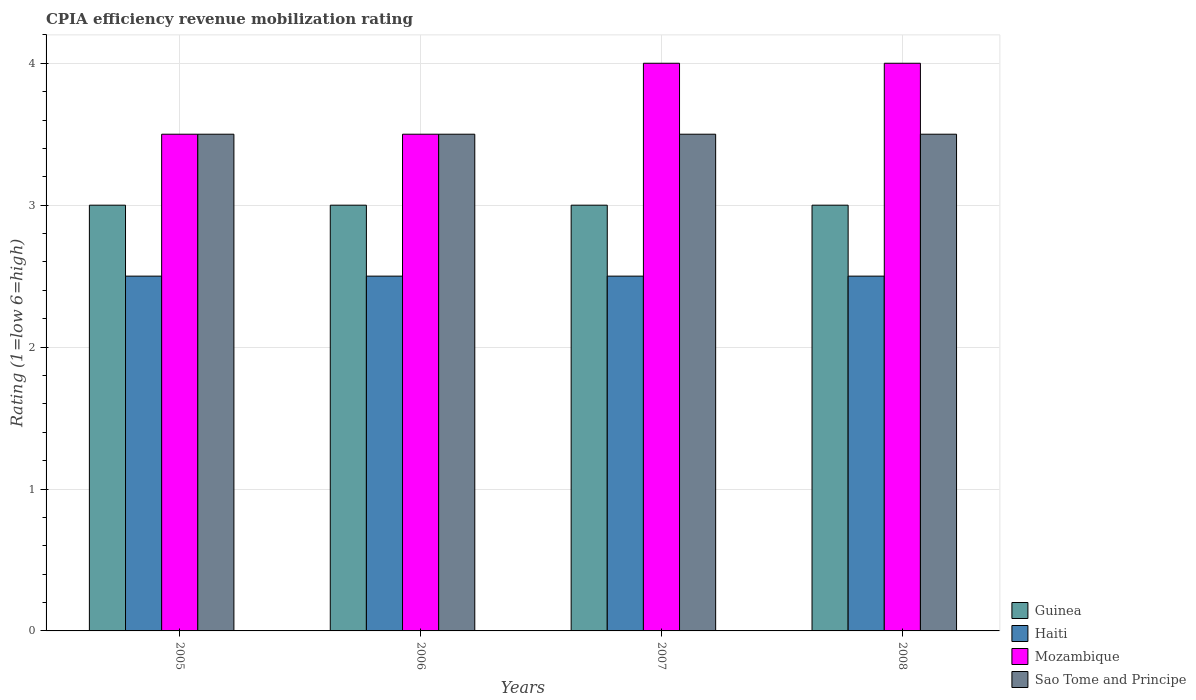How many different coloured bars are there?
Make the answer very short. 4. Are the number of bars on each tick of the X-axis equal?
Offer a terse response. Yes. How many bars are there on the 3rd tick from the left?
Provide a short and direct response. 4. What is the label of the 3rd group of bars from the left?
Give a very brief answer. 2007. In how many cases, is the number of bars for a given year not equal to the number of legend labels?
Give a very brief answer. 0. What is the CPIA rating in Guinea in 2007?
Your answer should be very brief. 3. Across all years, what is the maximum CPIA rating in Mozambique?
Your answer should be very brief. 4. In which year was the CPIA rating in Mozambique minimum?
Make the answer very short. 2005. What is the difference between the CPIA rating in Sao Tome and Principe in 2007 and the CPIA rating in Haiti in 2005?
Give a very brief answer. 1. Is the CPIA rating in Haiti in 2005 less than that in 2007?
Give a very brief answer. No. What is the difference between the highest and the second highest CPIA rating in Sao Tome and Principe?
Ensure brevity in your answer.  0. In how many years, is the CPIA rating in Guinea greater than the average CPIA rating in Guinea taken over all years?
Offer a very short reply. 0. Is the sum of the CPIA rating in Sao Tome and Principe in 2006 and 2007 greater than the maximum CPIA rating in Haiti across all years?
Your answer should be compact. Yes. What does the 2nd bar from the left in 2008 represents?
Your answer should be compact. Haiti. What does the 2nd bar from the right in 2005 represents?
Offer a terse response. Mozambique. How many bars are there?
Your answer should be very brief. 16. Are the values on the major ticks of Y-axis written in scientific E-notation?
Provide a succinct answer. No. Does the graph contain any zero values?
Keep it short and to the point. No. Where does the legend appear in the graph?
Make the answer very short. Bottom right. How many legend labels are there?
Offer a very short reply. 4. What is the title of the graph?
Your response must be concise. CPIA efficiency revenue mobilization rating. What is the label or title of the Y-axis?
Offer a very short reply. Rating (1=low 6=high). What is the Rating (1=low 6=high) in Guinea in 2005?
Keep it short and to the point. 3. What is the Rating (1=low 6=high) of Mozambique in 2005?
Offer a very short reply. 3.5. What is the Rating (1=low 6=high) in Sao Tome and Principe in 2005?
Provide a short and direct response. 3.5. What is the Rating (1=low 6=high) in Haiti in 2006?
Your answer should be compact. 2.5. What is the Rating (1=low 6=high) in Sao Tome and Principe in 2006?
Offer a terse response. 3.5. What is the Rating (1=low 6=high) in Guinea in 2007?
Your response must be concise. 3. What is the Rating (1=low 6=high) in Mozambique in 2007?
Your response must be concise. 4. What is the Rating (1=low 6=high) in Sao Tome and Principe in 2007?
Ensure brevity in your answer.  3.5. What is the Rating (1=low 6=high) of Guinea in 2008?
Ensure brevity in your answer.  3. What is the Rating (1=low 6=high) of Haiti in 2008?
Ensure brevity in your answer.  2.5. What is the Rating (1=low 6=high) in Mozambique in 2008?
Make the answer very short. 4. Across all years, what is the maximum Rating (1=low 6=high) in Guinea?
Provide a short and direct response. 3. Across all years, what is the maximum Rating (1=low 6=high) of Mozambique?
Offer a very short reply. 4. Across all years, what is the minimum Rating (1=low 6=high) of Guinea?
Your response must be concise. 3. Across all years, what is the minimum Rating (1=low 6=high) in Sao Tome and Principe?
Your answer should be very brief. 3.5. What is the total Rating (1=low 6=high) of Guinea in the graph?
Provide a short and direct response. 12. What is the total Rating (1=low 6=high) in Mozambique in the graph?
Give a very brief answer. 15. What is the total Rating (1=low 6=high) of Sao Tome and Principe in the graph?
Provide a short and direct response. 14. What is the difference between the Rating (1=low 6=high) in Guinea in 2005 and that in 2006?
Make the answer very short. 0. What is the difference between the Rating (1=low 6=high) in Haiti in 2005 and that in 2006?
Offer a very short reply. 0. What is the difference between the Rating (1=low 6=high) of Sao Tome and Principe in 2005 and that in 2007?
Provide a short and direct response. 0. What is the difference between the Rating (1=low 6=high) of Guinea in 2005 and that in 2008?
Ensure brevity in your answer.  0. What is the difference between the Rating (1=low 6=high) in Mozambique in 2005 and that in 2008?
Provide a succinct answer. -0.5. What is the difference between the Rating (1=low 6=high) of Sao Tome and Principe in 2005 and that in 2008?
Provide a short and direct response. 0. What is the difference between the Rating (1=low 6=high) of Mozambique in 2006 and that in 2007?
Keep it short and to the point. -0.5. What is the difference between the Rating (1=low 6=high) in Guinea in 2006 and that in 2008?
Keep it short and to the point. 0. What is the difference between the Rating (1=low 6=high) in Guinea in 2007 and that in 2008?
Your answer should be compact. 0. What is the difference between the Rating (1=low 6=high) of Haiti in 2007 and that in 2008?
Provide a short and direct response. 0. What is the difference between the Rating (1=low 6=high) in Sao Tome and Principe in 2007 and that in 2008?
Your answer should be compact. 0. What is the difference between the Rating (1=low 6=high) in Guinea in 2005 and the Rating (1=low 6=high) in Haiti in 2006?
Your answer should be compact. 0.5. What is the difference between the Rating (1=low 6=high) of Guinea in 2005 and the Rating (1=low 6=high) of Sao Tome and Principe in 2006?
Your response must be concise. -0.5. What is the difference between the Rating (1=low 6=high) in Haiti in 2005 and the Rating (1=low 6=high) in Mozambique in 2006?
Your response must be concise. -1. What is the difference between the Rating (1=low 6=high) of Haiti in 2005 and the Rating (1=low 6=high) of Sao Tome and Principe in 2006?
Offer a very short reply. -1. What is the difference between the Rating (1=low 6=high) of Mozambique in 2005 and the Rating (1=low 6=high) of Sao Tome and Principe in 2006?
Your answer should be very brief. 0. What is the difference between the Rating (1=low 6=high) in Guinea in 2005 and the Rating (1=low 6=high) in Mozambique in 2007?
Provide a short and direct response. -1. What is the difference between the Rating (1=low 6=high) of Guinea in 2005 and the Rating (1=low 6=high) of Sao Tome and Principe in 2007?
Your answer should be compact. -0.5. What is the difference between the Rating (1=low 6=high) in Haiti in 2005 and the Rating (1=low 6=high) in Sao Tome and Principe in 2007?
Your answer should be compact. -1. What is the difference between the Rating (1=low 6=high) in Mozambique in 2005 and the Rating (1=low 6=high) in Sao Tome and Principe in 2007?
Give a very brief answer. 0. What is the difference between the Rating (1=low 6=high) in Guinea in 2005 and the Rating (1=low 6=high) in Haiti in 2008?
Ensure brevity in your answer.  0.5. What is the difference between the Rating (1=low 6=high) in Guinea in 2005 and the Rating (1=low 6=high) in Mozambique in 2008?
Offer a terse response. -1. What is the difference between the Rating (1=low 6=high) in Haiti in 2005 and the Rating (1=low 6=high) in Mozambique in 2008?
Keep it short and to the point. -1.5. What is the difference between the Rating (1=low 6=high) in Haiti in 2005 and the Rating (1=low 6=high) in Sao Tome and Principe in 2008?
Provide a succinct answer. -1. What is the difference between the Rating (1=low 6=high) in Mozambique in 2005 and the Rating (1=low 6=high) in Sao Tome and Principe in 2008?
Your answer should be very brief. 0. What is the difference between the Rating (1=low 6=high) in Guinea in 2006 and the Rating (1=low 6=high) in Haiti in 2007?
Give a very brief answer. 0.5. What is the difference between the Rating (1=low 6=high) in Guinea in 2006 and the Rating (1=low 6=high) in Mozambique in 2007?
Make the answer very short. -1. What is the difference between the Rating (1=low 6=high) of Guinea in 2006 and the Rating (1=low 6=high) of Haiti in 2008?
Keep it short and to the point. 0.5. What is the difference between the Rating (1=low 6=high) in Guinea in 2006 and the Rating (1=low 6=high) in Mozambique in 2008?
Keep it short and to the point. -1. What is the difference between the Rating (1=low 6=high) in Haiti in 2006 and the Rating (1=low 6=high) in Mozambique in 2008?
Keep it short and to the point. -1.5. What is the difference between the Rating (1=low 6=high) of Guinea in 2007 and the Rating (1=low 6=high) of Mozambique in 2008?
Your answer should be compact. -1. What is the difference between the Rating (1=low 6=high) of Guinea in 2007 and the Rating (1=low 6=high) of Sao Tome and Principe in 2008?
Give a very brief answer. -0.5. What is the difference between the Rating (1=low 6=high) of Haiti in 2007 and the Rating (1=low 6=high) of Mozambique in 2008?
Provide a succinct answer. -1.5. What is the difference between the Rating (1=low 6=high) in Mozambique in 2007 and the Rating (1=low 6=high) in Sao Tome and Principe in 2008?
Ensure brevity in your answer.  0.5. What is the average Rating (1=low 6=high) in Guinea per year?
Ensure brevity in your answer.  3. What is the average Rating (1=low 6=high) in Mozambique per year?
Offer a terse response. 3.75. In the year 2005, what is the difference between the Rating (1=low 6=high) in Guinea and Rating (1=low 6=high) in Haiti?
Your answer should be compact. 0.5. In the year 2005, what is the difference between the Rating (1=low 6=high) in Haiti and Rating (1=low 6=high) in Sao Tome and Principe?
Your response must be concise. -1. In the year 2005, what is the difference between the Rating (1=low 6=high) of Mozambique and Rating (1=low 6=high) of Sao Tome and Principe?
Provide a succinct answer. 0. In the year 2006, what is the difference between the Rating (1=low 6=high) in Guinea and Rating (1=low 6=high) in Sao Tome and Principe?
Provide a succinct answer. -0.5. In the year 2006, what is the difference between the Rating (1=low 6=high) in Haiti and Rating (1=low 6=high) in Sao Tome and Principe?
Provide a succinct answer. -1. In the year 2007, what is the difference between the Rating (1=low 6=high) in Guinea and Rating (1=low 6=high) in Haiti?
Provide a short and direct response. 0.5. In the year 2007, what is the difference between the Rating (1=low 6=high) in Guinea and Rating (1=low 6=high) in Mozambique?
Keep it short and to the point. -1. In the year 2007, what is the difference between the Rating (1=low 6=high) in Guinea and Rating (1=low 6=high) in Sao Tome and Principe?
Offer a very short reply. -0.5. In the year 2007, what is the difference between the Rating (1=low 6=high) in Mozambique and Rating (1=low 6=high) in Sao Tome and Principe?
Provide a succinct answer. 0.5. In the year 2008, what is the difference between the Rating (1=low 6=high) in Guinea and Rating (1=low 6=high) in Haiti?
Your answer should be very brief. 0.5. In the year 2008, what is the difference between the Rating (1=low 6=high) in Guinea and Rating (1=low 6=high) in Sao Tome and Principe?
Make the answer very short. -0.5. In the year 2008, what is the difference between the Rating (1=low 6=high) of Haiti and Rating (1=low 6=high) of Mozambique?
Make the answer very short. -1.5. In the year 2008, what is the difference between the Rating (1=low 6=high) of Mozambique and Rating (1=low 6=high) of Sao Tome and Principe?
Give a very brief answer. 0.5. What is the ratio of the Rating (1=low 6=high) in Haiti in 2005 to that in 2006?
Your response must be concise. 1. What is the ratio of the Rating (1=low 6=high) in Sao Tome and Principe in 2005 to that in 2006?
Provide a short and direct response. 1. What is the ratio of the Rating (1=low 6=high) in Guinea in 2005 to that in 2007?
Offer a terse response. 1. What is the ratio of the Rating (1=low 6=high) of Mozambique in 2005 to that in 2007?
Your response must be concise. 0.88. What is the ratio of the Rating (1=low 6=high) in Mozambique in 2005 to that in 2008?
Keep it short and to the point. 0.88. What is the ratio of the Rating (1=low 6=high) in Sao Tome and Principe in 2005 to that in 2008?
Offer a very short reply. 1. What is the ratio of the Rating (1=low 6=high) in Haiti in 2006 to that in 2007?
Your answer should be very brief. 1. What is the ratio of the Rating (1=low 6=high) in Mozambique in 2006 to that in 2007?
Offer a very short reply. 0.88. What is the ratio of the Rating (1=low 6=high) in Sao Tome and Principe in 2006 to that in 2007?
Your answer should be very brief. 1. What is the ratio of the Rating (1=low 6=high) in Haiti in 2006 to that in 2008?
Your answer should be compact. 1. What is the ratio of the Rating (1=low 6=high) of Guinea in 2007 to that in 2008?
Provide a succinct answer. 1. What is the ratio of the Rating (1=low 6=high) in Haiti in 2007 to that in 2008?
Ensure brevity in your answer.  1. What is the ratio of the Rating (1=low 6=high) in Mozambique in 2007 to that in 2008?
Your response must be concise. 1. What is the ratio of the Rating (1=low 6=high) of Sao Tome and Principe in 2007 to that in 2008?
Make the answer very short. 1. What is the difference between the highest and the second highest Rating (1=low 6=high) in Guinea?
Your answer should be very brief. 0. What is the difference between the highest and the second highest Rating (1=low 6=high) in Haiti?
Ensure brevity in your answer.  0. What is the difference between the highest and the second highest Rating (1=low 6=high) of Mozambique?
Your answer should be very brief. 0. What is the difference between the highest and the lowest Rating (1=low 6=high) of Haiti?
Offer a terse response. 0. What is the difference between the highest and the lowest Rating (1=low 6=high) of Mozambique?
Your response must be concise. 0.5. What is the difference between the highest and the lowest Rating (1=low 6=high) of Sao Tome and Principe?
Offer a very short reply. 0. 